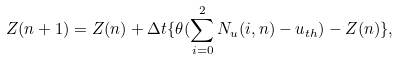<formula> <loc_0><loc_0><loc_500><loc_500>Z ( n + 1 ) = Z ( n ) + \Delta t \{ \theta ( \sum _ { i = 0 } ^ { 2 } N _ { u } ( i , n ) - u _ { t h } ) - Z ( n ) \} ,</formula> 